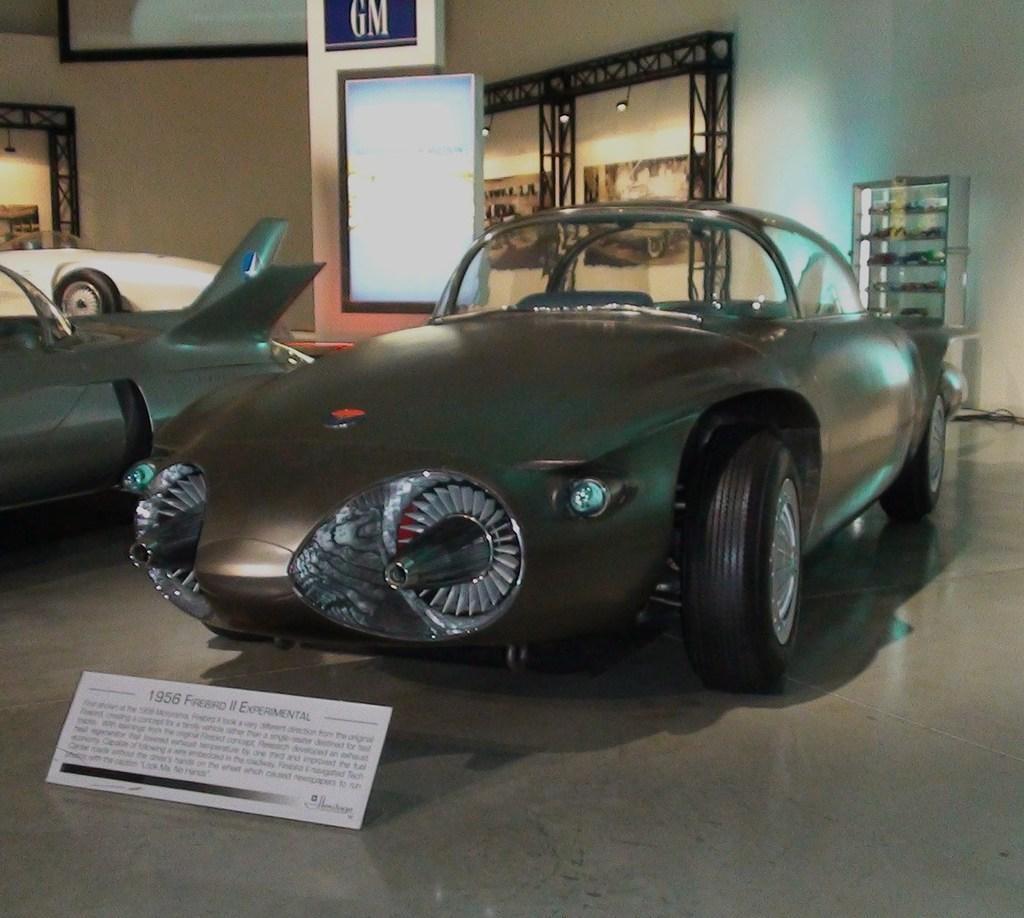Please provide a concise description of this image. In this image we can see vehicles, name board and other objects. In the background of the image there are frames, name board, lights, iron objects, wall and other objects. 